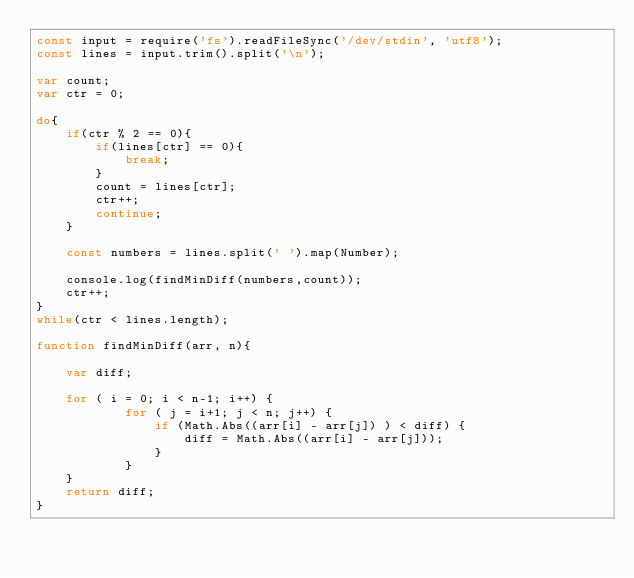<code> <loc_0><loc_0><loc_500><loc_500><_JavaScript_>const input = require('fs').readFileSync('/dev/stdin', 'utf8');
const lines = input.trim().split('\n');

var count;
var ctr = 0;

do{
    if(ctr % 2 == 0){
        if(lines[ctr] == 0){
            break;
        }
        count = lines[ctr];
        ctr++;
        continue;
    }

    const numbers = lines.split(' ').map(Number);

    console.log(findMinDiff(numbers,count));
    ctr++;
}
while(ctr < lines.length);

function findMinDiff(arr, n){

    var diff;

    for ( i = 0; i < n-1; i++) {
            for ( j = i+1; j < n; j++) {
                if (Math.Abs((arr[i] - arr[j]) ) < diff) {
                    diff = Math.Abs((arr[i] - arr[j]));
                }
            }
    }
    return diff;
}
</code> 